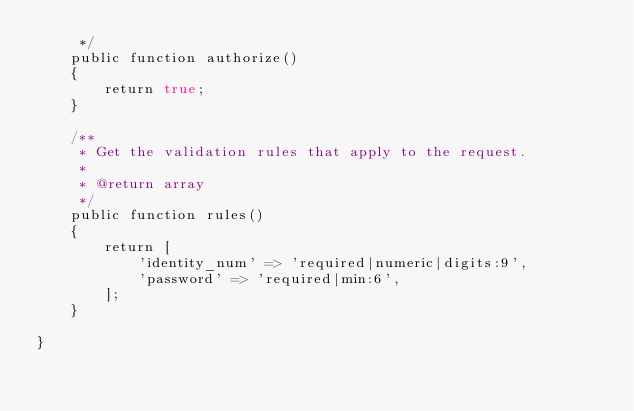Convert code to text. <code><loc_0><loc_0><loc_500><loc_500><_PHP_>     */
    public function authorize()
    {
        return true;
    }

    /**
     * Get the validation rules that apply to the request.
     *
     * @return array
     */
    public function rules()
    {
        return [
            'identity_num' => 'required|numeric|digits:9',
            'password' => 'required|min:6',
        ];
    }

}
</code> 